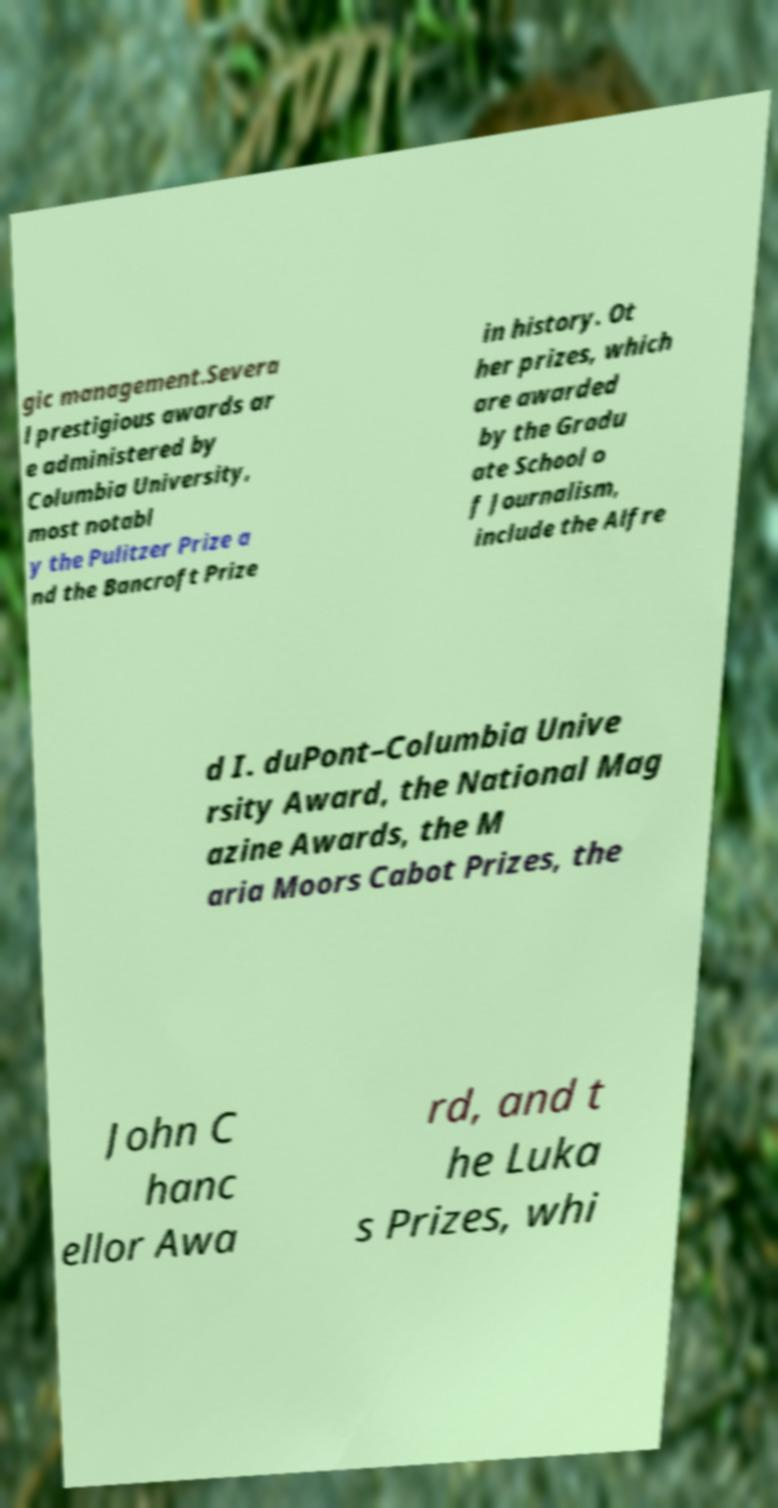For documentation purposes, I need the text within this image transcribed. Could you provide that? gic management.Severa l prestigious awards ar e administered by Columbia University, most notabl y the Pulitzer Prize a nd the Bancroft Prize in history. Ot her prizes, which are awarded by the Gradu ate School o f Journalism, include the Alfre d I. duPont–Columbia Unive rsity Award, the National Mag azine Awards, the M aria Moors Cabot Prizes, the John C hanc ellor Awa rd, and t he Luka s Prizes, whi 